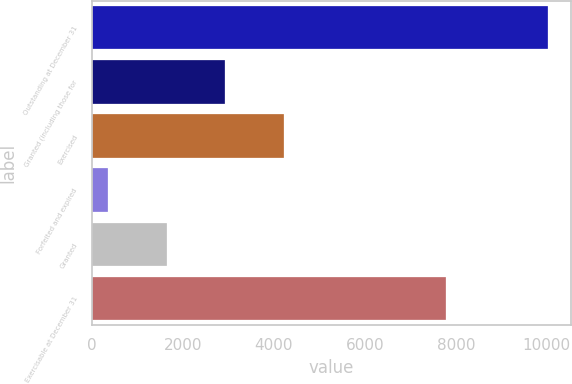<chart> <loc_0><loc_0><loc_500><loc_500><bar_chart><fcel>Outstanding at December 31<fcel>Granted (including those for<fcel>Exercised<fcel>Forfeited and expired<fcel>Granted<fcel>Exercisable at December 31<nl><fcel>10022<fcel>2928.6<fcel>4218.4<fcel>349<fcel>1638.8<fcel>7787<nl></chart> 